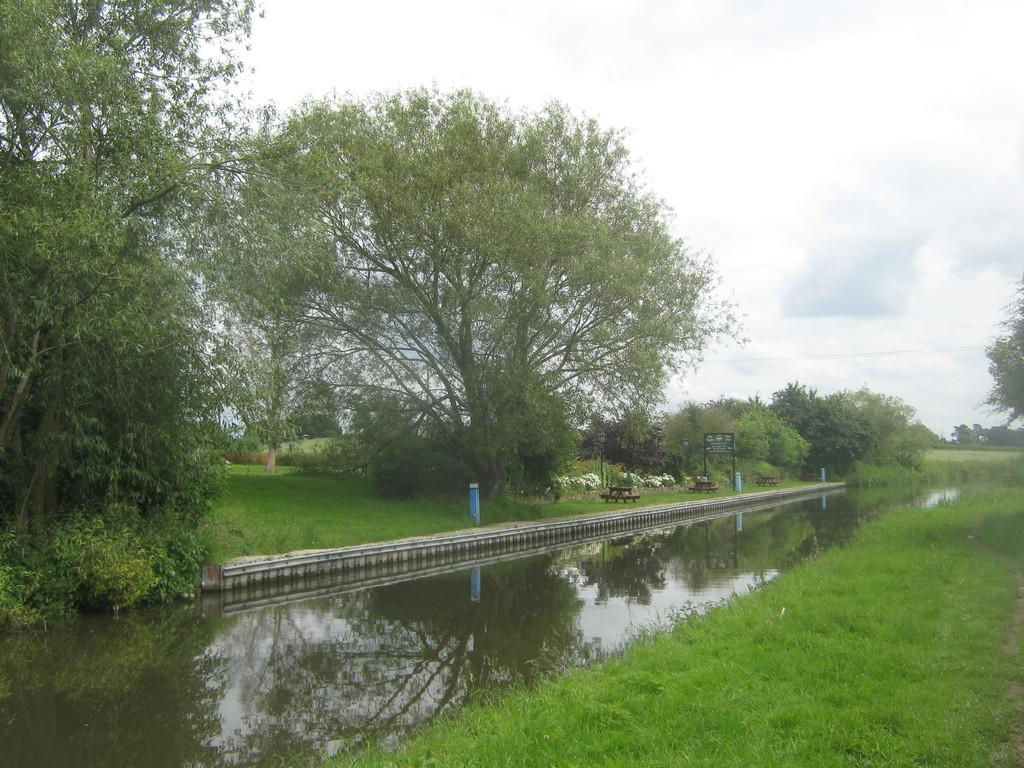What is the main feature of the landscape in the image? There is a large body of water in the image. What type of vegetation can be seen in the image? There are trees and grass in the image. Are there any man-made structures visible in the image? Yes, there is at least one building in the image. Can you describe any other objects present in the image? There are other unspecified objects in the image. What advice does the large body of water give to the trees in the image? The large body of water does not give advice to the trees in the image, as it is an inanimate object and cannot communicate. 